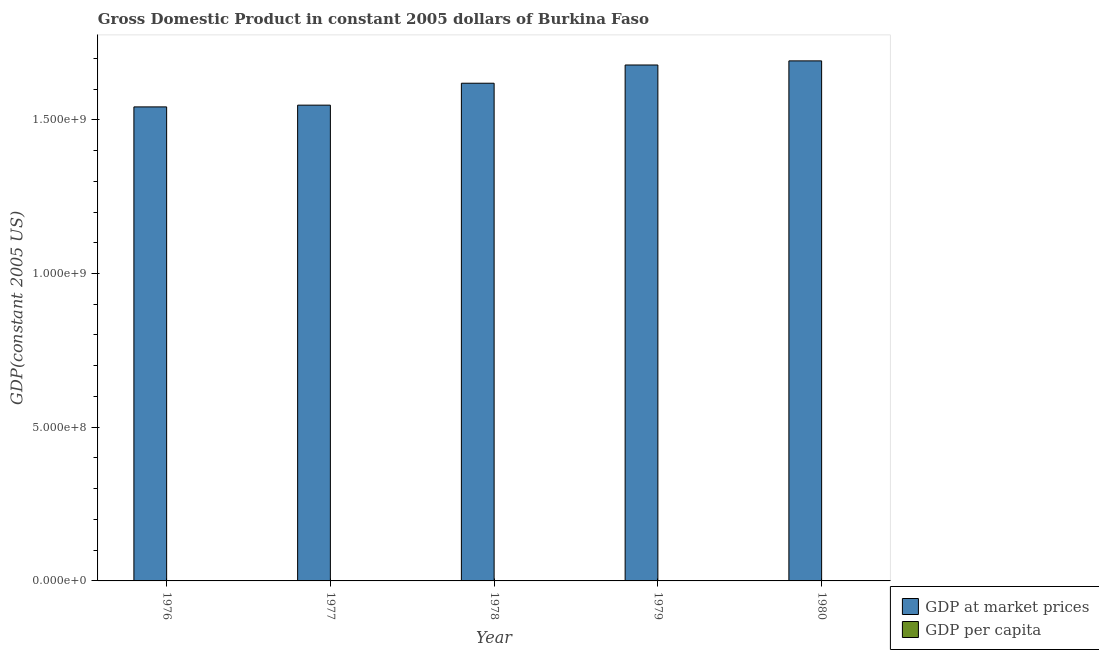Are the number of bars on each tick of the X-axis equal?
Give a very brief answer. Yes. How many bars are there on the 3rd tick from the right?
Ensure brevity in your answer.  2. What is the label of the 4th group of bars from the left?
Ensure brevity in your answer.  1979. What is the gdp per capita in 1977?
Ensure brevity in your answer.  241.86. Across all years, what is the maximum gdp at market prices?
Give a very brief answer. 1.69e+09. Across all years, what is the minimum gdp per capita?
Keep it short and to the point. 241.86. In which year was the gdp at market prices minimum?
Your answer should be very brief. 1976. What is the total gdp at market prices in the graph?
Make the answer very short. 8.08e+09. What is the difference between the gdp per capita in 1977 and that in 1979?
Offer a very short reply. -9.7. What is the difference between the gdp per capita in 1977 and the gdp at market prices in 1978?
Provide a short and direct response. -6.04. What is the average gdp per capita per year?
Provide a short and direct response. 247.01. What is the ratio of the gdp per capita in 1978 to that in 1980?
Your answer should be compact. 1. Is the gdp per capita in 1977 less than that in 1980?
Make the answer very short. Yes. What is the difference between the highest and the second highest gdp at market prices?
Make the answer very short. 1.34e+07. What is the difference between the highest and the lowest gdp at market prices?
Provide a short and direct response. 1.50e+08. In how many years, is the gdp at market prices greater than the average gdp at market prices taken over all years?
Your answer should be very brief. 3. Is the sum of the gdp at market prices in 1977 and 1979 greater than the maximum gdp per capita across all years?
Your answer should be compact. Yes. What does the 1st bar from the left in 1977 represents?
Provide a short and direct response. GDP at market prices. What does the 2nd bar from the right in 1976 represents?
Your answer should be compact. GDP at market prices. Are all the bars in the graph horizontal?
Your response must be concise. No. How many years are there in the graph?
Give a very brief answer. 5. Where does the legend appear in the graph?
Your answer should be very brief. Bottom right. What is the title of the graph?
Your response must be concise. Gross Domestic Product in constant 2005 dollars of Burkina Faso. Does "Underweight" appear as one of the legend labels in the graph?
Give a very brief answer. No. What is the label or title of the X-axis?
Offer a terse response. Year. What is the label or title of the Y-axis?
Give a very brief answer. GDP(constant 2005 US). What is the GDP(constant 2005 US) of GDP at market prices in 1976?
Offer a terse response. 1.54e+09. What is the GDP(constant 2005 US) in GDP per capita in 1976?
Your answer should be very brief. 245.77. What is the GDP(constant 2005 US) in GDP at market prices in 1977?
Your answer should be compact. 1.55e+09. What is the GDP(constant 2005 US) of GDP per capita in 1977?
Provide a succinct answer. 241.86. What is the GDP(constant 2005 US) of GDP at market prices in 1978?
Your answer should be compact. 1.62e+09. What is the GDP(constant 2005 US) of GDP per capita in 1978?
Give a very brief answer. 247.9. What is the GDP(constant 2005 US) in GDP at market prices in 1979?
Your answer should be compact. 1.68e+09. What is the GDP(constant 2005 US) of GDP per capita in 1979?
Provide a succinct answer. 251.56. What is the GDP(constant 2005 US) in GDP at market prices in 1980?
Your answer should be compact. 1.69e+09. What is the GDP(constant 2005 US) of GDP per capita in 1980?
Provide a short and direct response. 247.94. Across all years, what is the maximum GDP(constant 2005 US) in GDP at market prices?
Your response must be concise. 1.69e+09. Across all years, what is the maximum GDP(constant 2005 US) in GDP per capita?
Offer a very short reply. 251.56. Across all years, what is the minimum GDP(constant 2005 US) in GDP at market prices?
Your response must be concise. 1.54e+09. Across all years, what is the minimum GDP(constant 2005 US) of GDP per capita?
Keep it short and to the point. 241.86. What is the total GDP(constant 2005 US) in GDP at market prices in the graph?
Your answer should be compact. 8.08e+09. What is the total GDP(constant 2005 US) in GDP per capita in the graph?
Give a very brief answer. 1235.03. What is the difference between the GDP(constant 2005 US) of GDP at market prices in 1976 and that in 1977?
Provide a short and direct response. -5.71e+06. What is the difference between the GDP(constant 2005 US) in GDP per capita in 1976 and that in 1977?
Offer a terse response. 3.9. What is the difference between the GDP(constant 2005 US) of GDP at market prices in 1976 and that in 1978?
Make the answer very short. -7.70e+07. What is the difference between the GDP(constant 2005 US) of GDP per capita in 1976 and that in 1978?
Keep it short and to the point. -2.13. What is the difference between the GDP(constant 2005 US) of GDP at market prices in 1976 and that in 1979?
Offer a terse response. -1.36e+08. What is the difference between the GDP(constant 2005 US) of GDP per capita in 1976 and that in 1979?
Your response must be concise. -5.79. What is the difference between the GDP(constant 2005 US) of GDP at market prices in 1976 and that in 1980?
Ensure brevity in your answer.  -1.50e+08. What is the difference between the GDP(constant 2005 US) in GDP per capita in 1976 and that in 1980?
Keep it short and to the point. -2.18. What is the difference between the GDP(constant 2005 US) in GDP at market prices in 1977 and that in 1978?
Your answer should be compact. -7.13e+07. What is the difference between the GDP(constant 2005 US) in GDP per capita in 1977 and that in 1978?
Your answer should be very brief. -6.04. What is the difference between the GDP(constant 2005 US) of GDP at market prices in 1977 and that in 1979?
Keep it short and to the point. -1.31e+08. What is the difference between the GDP(constant 2005 US) of GDP per capita in 1977 and that in 1979?
Give a very brief answer. -9.7. What is the difference between the GDP(constant 2005 US) of GDP at market prices in 1977 and that in 1980?
Your answer should be very brief. -1.44e+08. What is the difference between the GDP(constant 2005 US) of GDP per capita in 1977 and that in 1980?
Offer a terse response. -6.08. What is the difference between the GDP(constant 2005 US) in GDP at market prices in 1978 and that in 1979?
Offer a very short reply. -5.93e+07. What is the difference between the GDP(constant 2005 US) of GDP per capita in 1978 and that in 1979?
Give a very brief answer. -3.66. What is the difference between the GDP(constant 2005 US) of GDP at market prices in 1978 and that in 1980?
Give a very brief answer. -7.27e+07. What is the difference between the GDP(constant 2005 US) in GDP per capita in 1978 and that in 1980?
Your answer should be compact. -0.05. What is the difference between the GDP(constant 2005 US) of GDP at market prices in 1979 and that in 1980?
Ensure brevity in your answer.  -1.34e+07. What is the difference between the GDP(constant 2005 US) in GDP per capita in 1979 and that in 1980?
Keep it short and to the point. 3.61. What is the difference between the GDP(constant 2005 US) of GDP at market prices in 1976 and the GDP(constant 2005 US) of GDP per capita in 1977?
Keep it short and to the point. 1.54e+09. What is the difference between the GDP(constant 2005 US) in GDP at market prices in 1976 and the GDP(constant 2005 US) in GDP per capita in 1978?
Make the answer very short. 1.54e+09. What is the difference between the GDP(constant 2005 US) of GDP at market prices in 1976 and the GDP(constant 2005 US) of GDP per capita in 1979?
Offer a very short reply. 1.54e+09. What is the difference between the GDP(constant 2005 US) of GDP at market prices in 1976 and the GDP(constant 2005 US) of GDP per capita in 1980?
Offer a terse response. 1.54e+09. What is the difference between the GDP(constant 2005 US) of GDP at market prices in 1977 and the GDP(constant 2005 US) of GDP per capita in 1978?
Keep it short and to the point. 1.55e+09. What is the difference between the GDP(constant 2005 US) of GDP at market prices in 1977 and the GDP(constant 2005 US) of GDP per capita in 1979?
Offer a very short reply. 1.55e+09. What is the difference between the GDP(constant 2005 US) in GDP at market prices in 1977 and the GDP(constant 2005 US) in GDP per capita in 1980?
Give a very brief answer. 1.55e+09. What is the difference between the GDP(constant 2005 US) in GDP at market prices in 1978 and the GDP(constant 2005 US) in GDP per capita in 1979?
Keep it short and to the point. 1.62e+09. What is the difference between the GDP(constant 2005 US) of GDP at market prices in 1978 and the GDP(constant 2005 US) of GDP per capita in 1980?
Your answer should be compact. 1.62e+09. What is the difference between the GDP(constant 2005 US) in GDP at market prices in 1979 and the GDP(constant 2005 US) in GDP per capita in 1980?
Your answer should be compact. 1.68e+09. What is the average GDP(constant 2005 US) of GDP at market prices per year?
Your answer should be very brief. 1.62e+09. What is the average GDP(constant 2005 US) of GDP per capita per year?
Your response must be concise. 247.01. In the year 1976, what is the difference between the GDP(constant 2005 US) in GDP at market prices and GDP(constant 2005 US) in GDP per capita?
Ensure brevity in your answer.  1.54e+09. In the year 1977, what is the difference between the GDP(constant 2005 US) of GDP at market prices and GDP(constant 2005 US) of GDP per capita?
Make the answer very short. 1.55e+09. In the year 1978, what is the difference between the GDP(constant 2005 US) in GDP at market prices and GDP(constant 2005 US) in GDP per capita?
Your answer should be compact. 1.62e+09. In the year 1979, what is the difference between the GDP(constant 2005 US) of GDP at market prices and GDP(constant 2005 US) of GDP per capita?
Provide a short and direct response. 1.68e+09. In the year 1980, what is the difference between the GDP(constant 2005 US) of GDP at market prices and GDP(constant 2005 US) of GDP per capita?
Ensure brevity in your answer.  1.69e+09. What is the ratio of the GDP(constant 2005 US) of GDP at market prices in 1976 to that in 1977?
Your answer should be compact. 1. What is the ratio of the GDP(constant 2005 US) of GDP per capita in 1976 to that in 1977?
Ensure brevity in your answer.  1.02. What is the ratio of the GDP(constant 2005 US) in GDP at market prices in 1976 to that in 1978?
Offer a very short reply. 0.95. What is the ratio of the GDP(constant 2005 US) in GDP per capita in 1976 to that in 1978?
Keep it short and to the point. 0.99. What is the ratio of the GDP(constant 2005 US) of GDP at market prices in 1976 to that in 1979?
Your answer should be compact. 0.92. What is the ratio of the GDP(constant 2005 US) of GDP per capita in 1976 to that in 1979?
Ensure brevity in your answer.  0.98. What is the ratio of the GDP(constant 2005 US) in GDP at market prices in 1976 to that in 1980?
Give a very brief answer. 0.91. What is the ratio of the GDP(constant 2005 US) of GDP at market prices in 1977 to that in 1978?
Keep it short and to the point. 0.96. What is the ratio of the GDP(constant 2005 US) of GDP per capita in 1977 to that in 1978?
Keep it short and to the point. 0.98. What is the ratio of the GDP(constant 2005 US) of GDP at market prices in 1977 to that in 1979?
Your response must be concise. 0.92. What is the ratio of the GDP(constant 2005 US) in GDP per capita in 1977 to that in 1979?
Make the answer very short. 0.96. What is the ratio of the GDP(constant 2005 US) in GDP at market prices in 1977 to that in 1980?
Your answer should be very brief. 0.91. What is the ratio of the GDP(constant 2005 US) of GDP per capita in 1977 to that in 1980?
Offer a very short reply. 0.98. What is the ratio of the GDP(constant 2005 US) of GDP at market prices in 1978 to that in 1979?
Make the answer very short. 0.96. What is the ratio of the GDP(constant 2005 US) in GDP per capita in 1978 to that in 1979?
Your response must be concise. 0.99. What is the ratio of the GDP(constant 2005 US) of GDP at market prices in 1979 to that in 1980?
Your response must be concise. 0.99. What is the ratio of the GDP(constant 2005 US) in GDP per capita in 1979 to that in 1980?
Provide a short and direct response. 1.01. What is the difference between the highest and the second highest GDP(constant 2005 US) in GDP at market prices?
Give a very brief answer. 1.34e+07. What is the difference between the highest and the second highest GDP(constant 2005 US) of GDP per capita?
Offer a very short reply. 3.61. What is the difference between the highest and the lowest GDP(constant 2005 US) in GDP at market prices?
Your answer should be compact. 1.50e+08. What is the difference between the highest and the lowest GDP(constant 2005 US) of GDP per capita?
Ensure brevity in your answer.  9.7. 